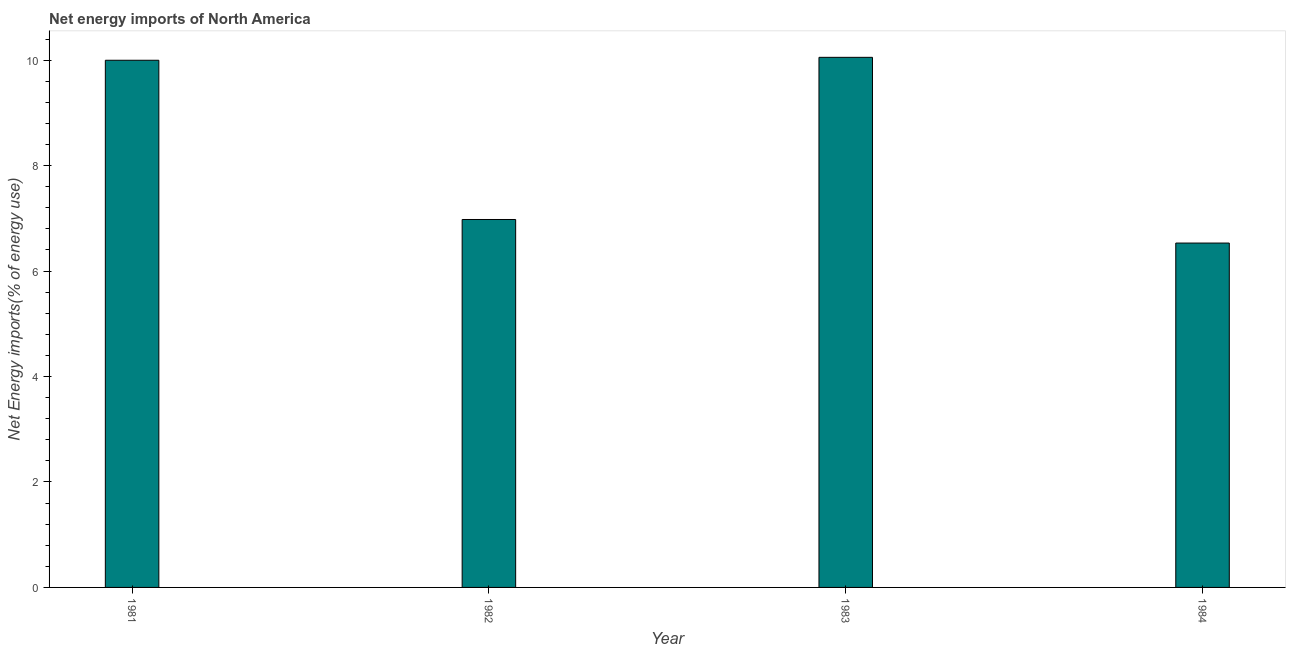Does the graph contain any zero values?
Your response must be concise. No. Does the graph contain grids?
Make the answer very short. No. What is the title of the graph?
Offer a very short reply. Net energy imports of North America. What is the label or title of the X-axis?
Ensure brevity in your answer.  Year. What is the label or title of the Y-axis?
Your response must be concise. Net Energy imports(% of energy use). What is the energy imports in 1982?
Give a very brief answer. 6.98. Across all years, what is the maximum energy imports?
Offer a very short reply. 10.05. Across all years, what is the minimum energy imports?
Make the answer very short. 6.53. In which year was the energy imports maximum?
Your answer should be compact. 1983. In which year was the energy imports minimum?
Make the answer very short. 1984. What is the sum of the energy imports?
Your answer should be very brief. 33.56. What is the difference between the energy imports in 1982 and 1983?
Offer a very short reply. -3.08. What is the average energy imports per year?
Ensure brevity in your answer.  8.39. What is the median energy imports?
Keep it short and to the point. 8.49. Do a majority of the years between 1983 and 1981 (inclusive) have energy imports greater than 5.6 %?
Your response must be concise. Yes. What is the ratio of the energy imports in 1983 to that in 1984?
Keep it short and to the point. 1.54. Is the difference between the energy imports in 1981 and 1982 greater than the difference between any two years?
Give a very brief answer. No. What is the difference between the highest and the second highest energy imports?
Offer a very short reply. 0.06. What is the difference between the highest and the lowest energy imports?
Your answer should be compact. 3.52. How many bars are there?
Offer a terse response. 4. Are all the bars in the graph horizontal?
Offer a very short reply. No. Are the values on the major ticks of Y-axis written in scientific E-notation?
Ensure brevity in your answer.  No. What is the Net Energy imports(% of energy use) in 1981?
Provide a short and direct response. 10. What is the Net Energy imports(% of energy use) of 1982?
Offer a terse response. 6.98. What is the Net Energy imports(% of energy use) in 1983?
Give a very brief answer. 10.05. What is the Net Energy imports(% of energy use) of 1984?
Keep it short and to the point. 6.53. What is the difference between the Net Energy imports(% of energy use) in 1981 and 1982?
Make the answer very short. 3.02. What is the difference between the Net Energy imports(% of energy use) in 1981 and 1983?
Offer a very short reply. -0.06. What is the difference between the Net Energy imports(% of energy use) in 1981 and 1984?
Give a very brief answer. 3.47. What is the difference between the Net Energy imports(% of energy use) in 1982 and 1983?
Provide a short and direct response. -3.08. What is the difference between the Net Energy imports(% of energy use) in 1982 and 1984?
Your response must be concise. 0.45. What is the difference between the Net Energy imports(% of energy use) in 1983 and 1984?
Ensure brevity in your answer.  3.52. What is the ratio of the Net Energy imports(% of energy use) in 1981 to that in 1982?
Ensure brevity in your answer.  1.43. What is the ratio of the Net Energy imports(% of energy use) in 1981 to that in 1984?
Your answer should be very brief. 1.53. What is the ratio of the Net Energy imports(% of energy use) in 1982 to that in 1983?
Provide a succinct answer. 0.69. What is the ratio of the Net Energy imports(% of energy use) in 1982 to that in 1984?
Give a very brief answer. 1.07. What is the ratio of the Net Energy imports(% of energy use) in 1983 to that in 1984?
Provide a succinct answer. 1.54. 